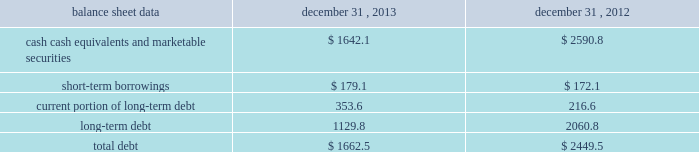Management 2019s discussion and analysis of financial condition and results of operations 2013 ( continued ) ( amounts in millions , except per share amounts ) net cash used in investing activities during 2012 primarily related to payments for capital expenditures and acquisitions , partially offset by the net proceeds of $ 94.8 received from the sale of our remaining holdings in facebook .
Capital expenditures of $ 169.2 primarily related to computer hardware and software , and leasehold improvements .
Capital expenditures increased in 2012 compared to the prior year , primarily due to an increase in leasehold improvements made during the year .
Payments for acquisitions of $ 145.5 primarily related to payments for new acquisitions .
Financing activities net cash used in financing activities during 2013 primarily related to the purchase of long-term debt , the repurchase of our common stock , and payment of dividends .
We redeemed all $ 600.0 in aggregate principal amount of our 10.00% ( 10.00 % ) notes .
In addition , we repurchased 31.8 shares of our common stock for an aggregate cost of $ 481.8 , including fees , and made dividend payments of $ 126.0 on our common stock .
Net cash provided by financing activities during 2012 primarily reflected net proceeds from our debt transactions .
We issued $ 300.0 in aggregate principal amount of 2.25% ( 2.25 % ) senior notes due 2017 ( the 201c2.25% ( 201c2.25 % ) notes 201d ) , $ 500.0 in aggregate principal amount of 3.75% ( 3.75 % ) senior notes due 2023 ( the 201c3.75% ( 201c3.75 % ) notes 201d ) and $ 250.0 in aggregate principal amount of 4.00% ( 4.00 % ) senior notes due 2022 ( the 201c4.00% ( 201c4.00 % ) notes 201d ) .
The proceeds from the issuance of the 4.00% ( 4.00 % ) notes were applied towards the repurchase and redemption of $ 399.6 in aggregate principal amount of our 4.25% ( 4.25 % ) notes .
Offsetting the net proceeds from our debt transactions was the repurchase of 32.7 shares of our common stock for an aggregate cost of $ 350.5 , including fees , and dividend payments of $ 103.4 on our common stock .
Foreign exchange rate changes the effect of foreign exchange rate changes on cash and cash equivalents included in the consolidated statements of cash flows resulted in a decrease of $ 94.1 in 2013 .
The decrease was primarily a result of the u.s .
Dollar being stronger than several foreign currencies , including the australian dollar , brazilian real , japanese yen , canadian dollar and south african rand as of december 31 , 2013 compared to december 31 , 2012 .
The effect of foreign exchange rate changes on cash and cash equivalents included in the consolidated statements of cash flows resulted in a decrease of $ 6.2 in 2012 .
The decrease was a result of the u.s .
Dollar being stronger than several foreign currencies , including the brazilian real and south african rand , offset by the u.s .
Dollar being weaker than other foreign currencies , including the australian dollar , british pound and the euro , as of as of december 31 , 2012 compared to december 31 , 2011. .
Liquidity outlook we expect our cash flow from operations , cash and cash equivalents to be sufficient to meet our anticipated operating requirements at a minimum for the next twelve months .
We also have a committed corporate credit facility as well as uncommitted facilities available to support our operating needs .
We continue to maintain a disciplined approach to managing liquidity , with flexibility over significant uses of cash , including our capital expenditures , cash used for new acquisitions , our common stock repurchase program and our common stock dividends. .
What percentage has liquidity dropped from 2012 to 2013? 
Rationale: to find out how much the liquidity has dropped from 2012 to 2013 you take 2013 number and divide it by 2012 to get 63.4% .
Computations: (1642.1 / 2590.8)
Answer: 0.63382. 